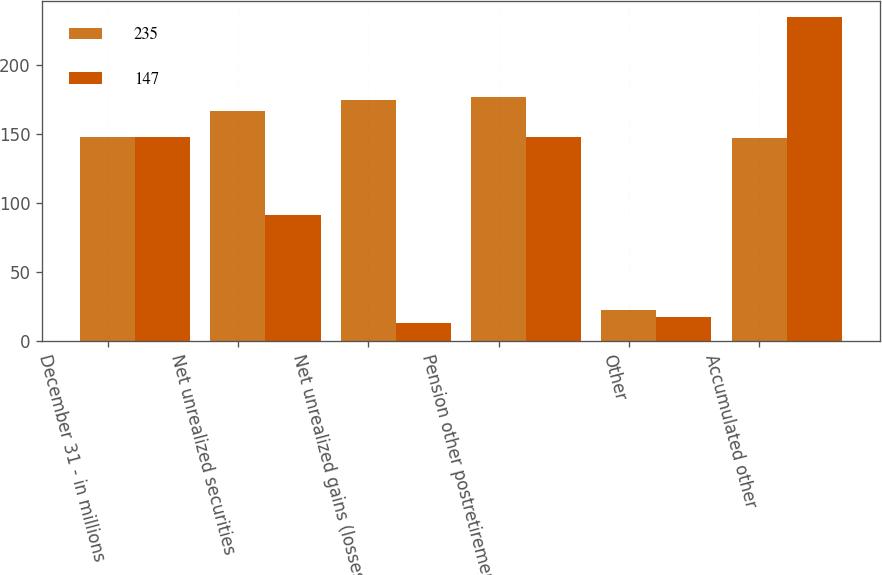Convert chart to OTSL. <chart><loc_0><loc_0><loc_500><loc_500><stacked_bar_chart><ecel><fcel>December 31 - in millions<fcel>Net unrealized securities<fcel>Net unrealized gains (losses)<fcel>Pension other postretirement<fcel>Other<fcel>Accumulated other<nl><fcel>235<fcel>147.5<fcel>167<fcel>175<fcel>177<fcel>22<fcel>147<nl><fcel>147<fcel>147.5<fcel>91<fcel>13<fcel>148<fcel>17<fcel>235<nl></chart> 